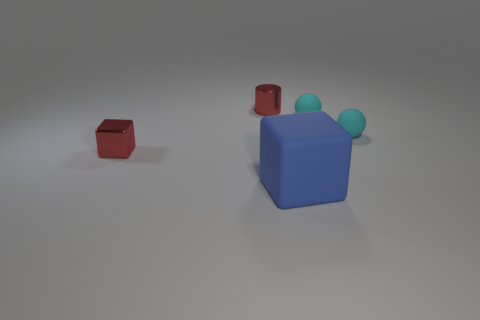Are there any other things that are the same size as the blue rubber cube?
Make the answer very short. No. What is the color of the rubber cube in front of the red cylinder?
Offer a very short reply. Blue. There is a thing that is behind the tiny cube and on the left side of the large blue matte object; what is its shape?
Offer a very short reply. Cylinder. How many large gray rubber things are the same shape as the big blue object?
Ensure brevity in your answer.  0. What number of small cyan matte things are there?
Keep it short and to the point. 2. There is a thing that is both in front of the small shiny cylinder and left of the large blue rubber cube; what is its size?
Make the answer very short. Small. The red object that is the same size as the metal cylinder is what shape?
Your answer should be very brief. Cube. There is a large matte cube in front of the tiny cylinder; are there any tiny cyan things in front of it?
Offer a terse response. No. There is another object that is the same shape as the blue thing; what is its color?
Keep it short and to the point. Red. There is a cube behind the big blue block; is it the same color as the tiny cylinder?
Provide a succinct answer. Yes. 